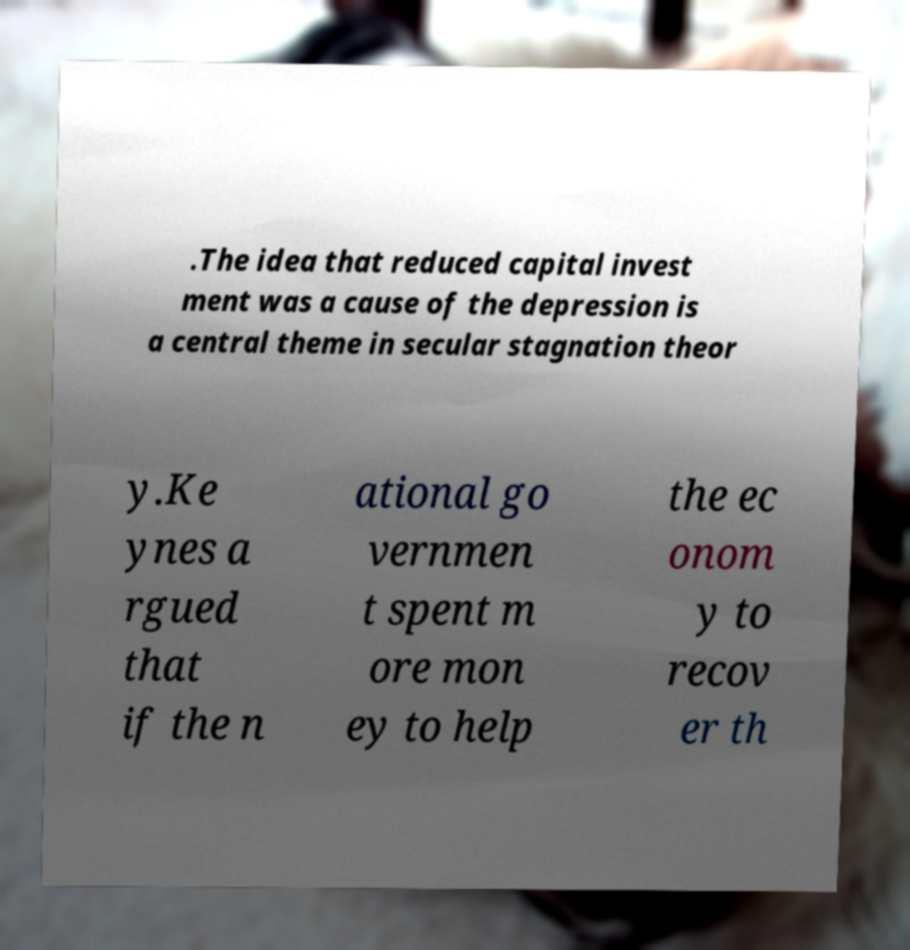Could you extract and type out the text from this image? .The idea that reduced capital invest ment was a cause of the depression is a central theme in secular stagnation theor y.Ke ynes a rgued that if the n ational go vernmen t spent m ore mon ey to help the ec onom y to recov er th 